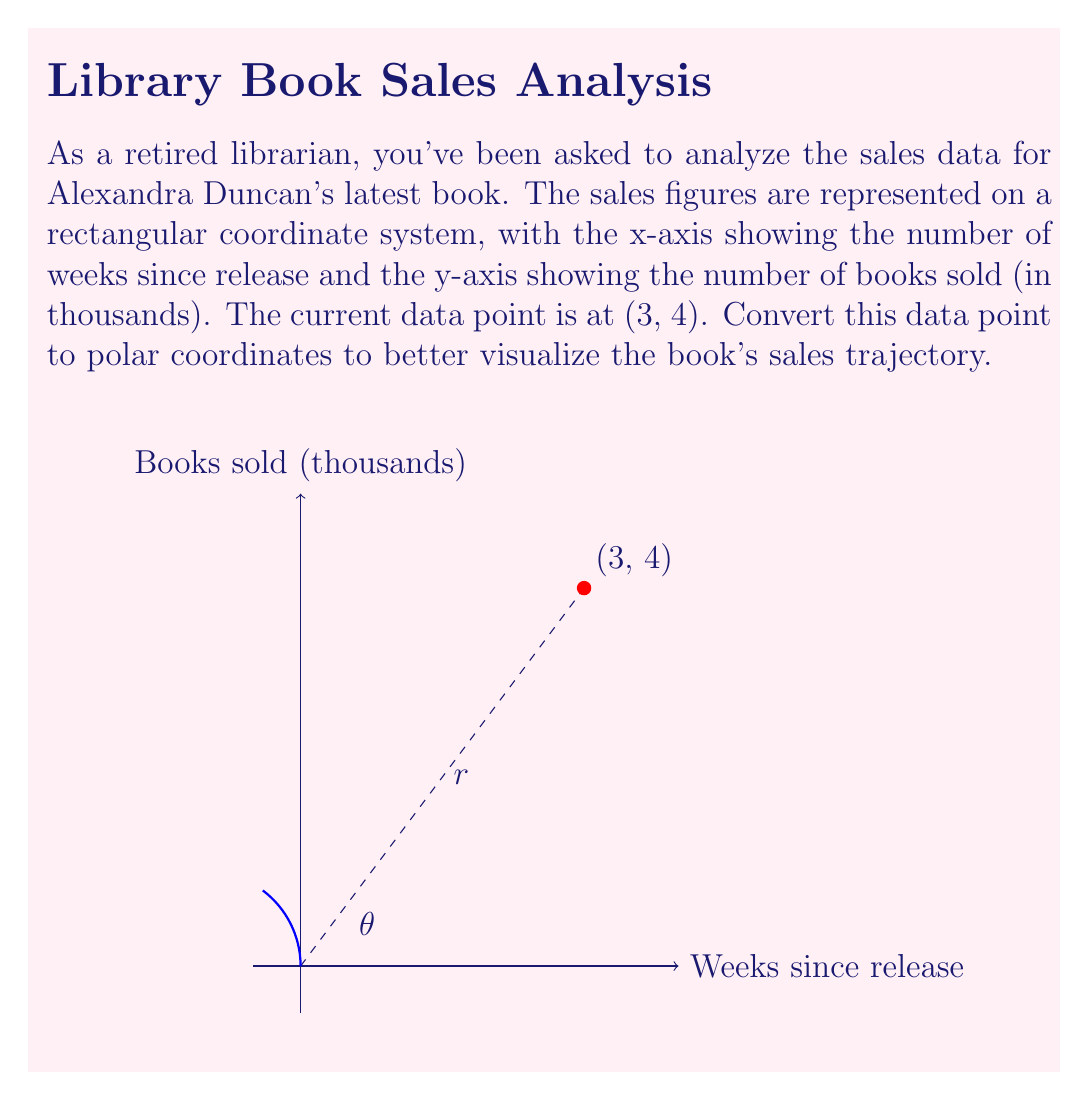Teach me how to tackle this problem. To convert from rectangular coordinates $(x, y)$ to polar coordinates $(r, \theta)$, we use the following formulas:

1) $r = \sqrt{x^2 + y^2}$
2) $\theta = \tan^{-1}(\frac{y}{x})$

For the given point (3, 4):

1) Calculate $r$:
   $r = \sqrt{3^2 + 4^2} = \sqrt{9 + 16} = \sqrt{25} = 5$

2) Calculate $\theta$:
   $\theta = \tan^{-1}(\frac{4}{3}) \approx 0.9273$ radians

To convert radians to degrees, multiply by $\frac{180°}{\pi}$:
$0.9273 \times \frac{180°}{\pi} \approx 53.13°$

Therefore, the polar coordinates are $(5, 53.13°)$ or $(5, 0.9273 \text{ radians})$.

In the context of book sales, $r$ represents the total sales momentum (combining time and quantity), while $\theta$ represents the sales rate (books sold per week).
Answer: $(5, 53.13°)$ or $(5, 0.9273 \text{ radians})$ 